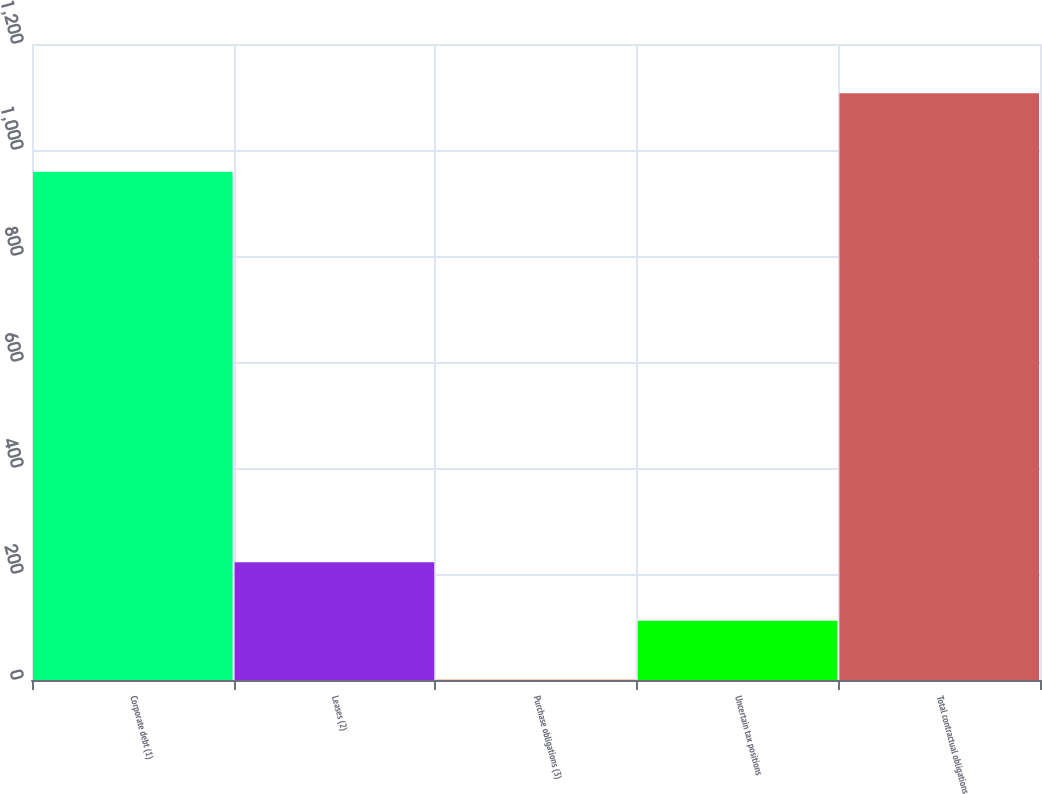<chart> <loc_0><loc_0><loc_500><loc_500><bar_chart><fcel>Corporate debt (1)<fcel>Leases (2)<fcel>Purchase obligations (3)<fcel>Uncertain tax positions<fcel>Total contractual obligations<nl><fcel>959<fcel>222.2<fcel>1<fcel>111.6<fcel>1107<nl></chart> 